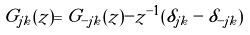<formula> <loc_0><loc_0><loc_500><loc_500>G _ { j k } ( z ) = G _ { - j k } ( z ) - z ^ { - 1 } ( \delta _ { j k } - \delta _ { - j k } )</formula> 